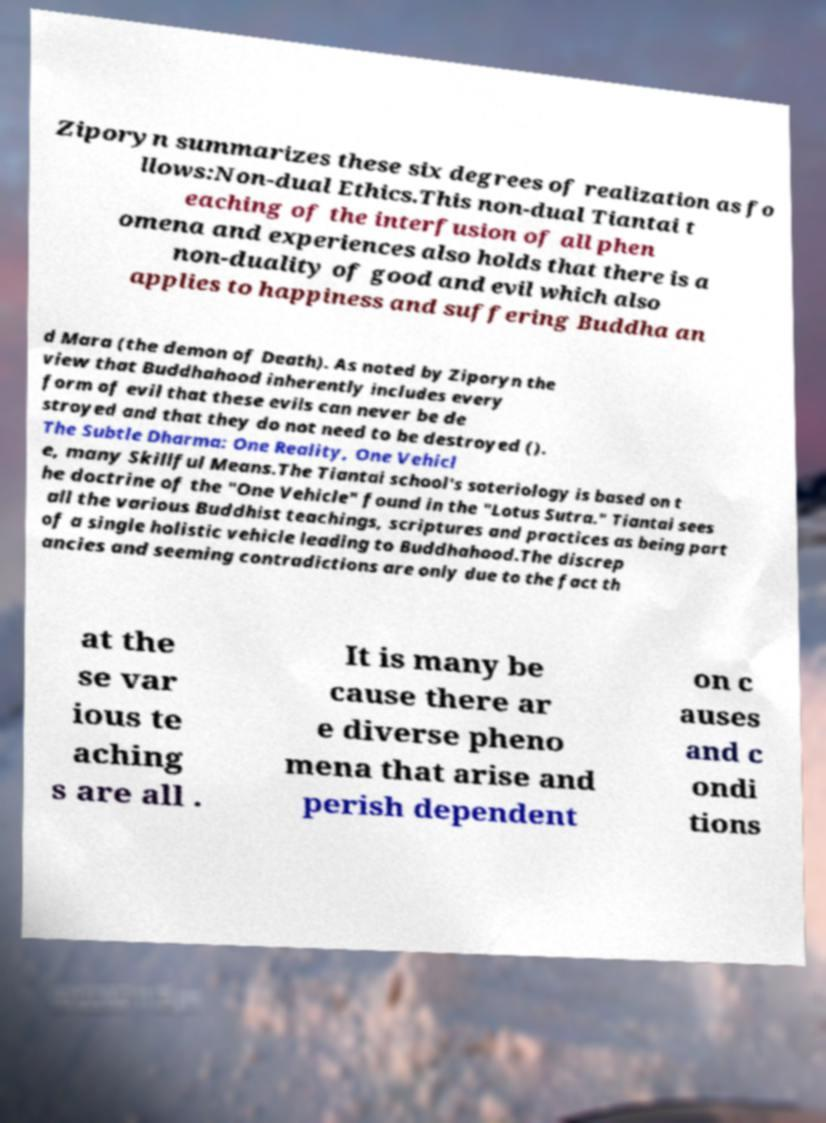Could you extract and type out the text from this image? Ziporyn summarizes these six degrees of realization as fo llows:Non-dual Ethics.This non-dual Tiantai t eaching of the interfusion of all phen omena and experiences also holds that there is a non-duality of good and evil which also applies to happiness and suffering Buddha an d Mara (the demon of Death). As noted by Ziporyn the view that Buddhahood inherently includes every form of evil that these evils can never be de stroyed and that they do not need to be destroyed (). The Subtle Dharma: One Reality, One Vehicl e, many Skillful Means.The Tiantai school's soteriology is based on t he doctrine of the "One Vehicle" found in the "Lotus Sutra." Tiantai sees all the various Buddhist teachings, scriptures and practices as being part of a single holistic vehicle leading to Buddhahood.The discrep ancies and seeming contradictions are only due to the fact th at the se var ious te aching s are all . It is many be cause there ar e diverse pheno mena that arise and perish dependent on c auses and c ondi tions 